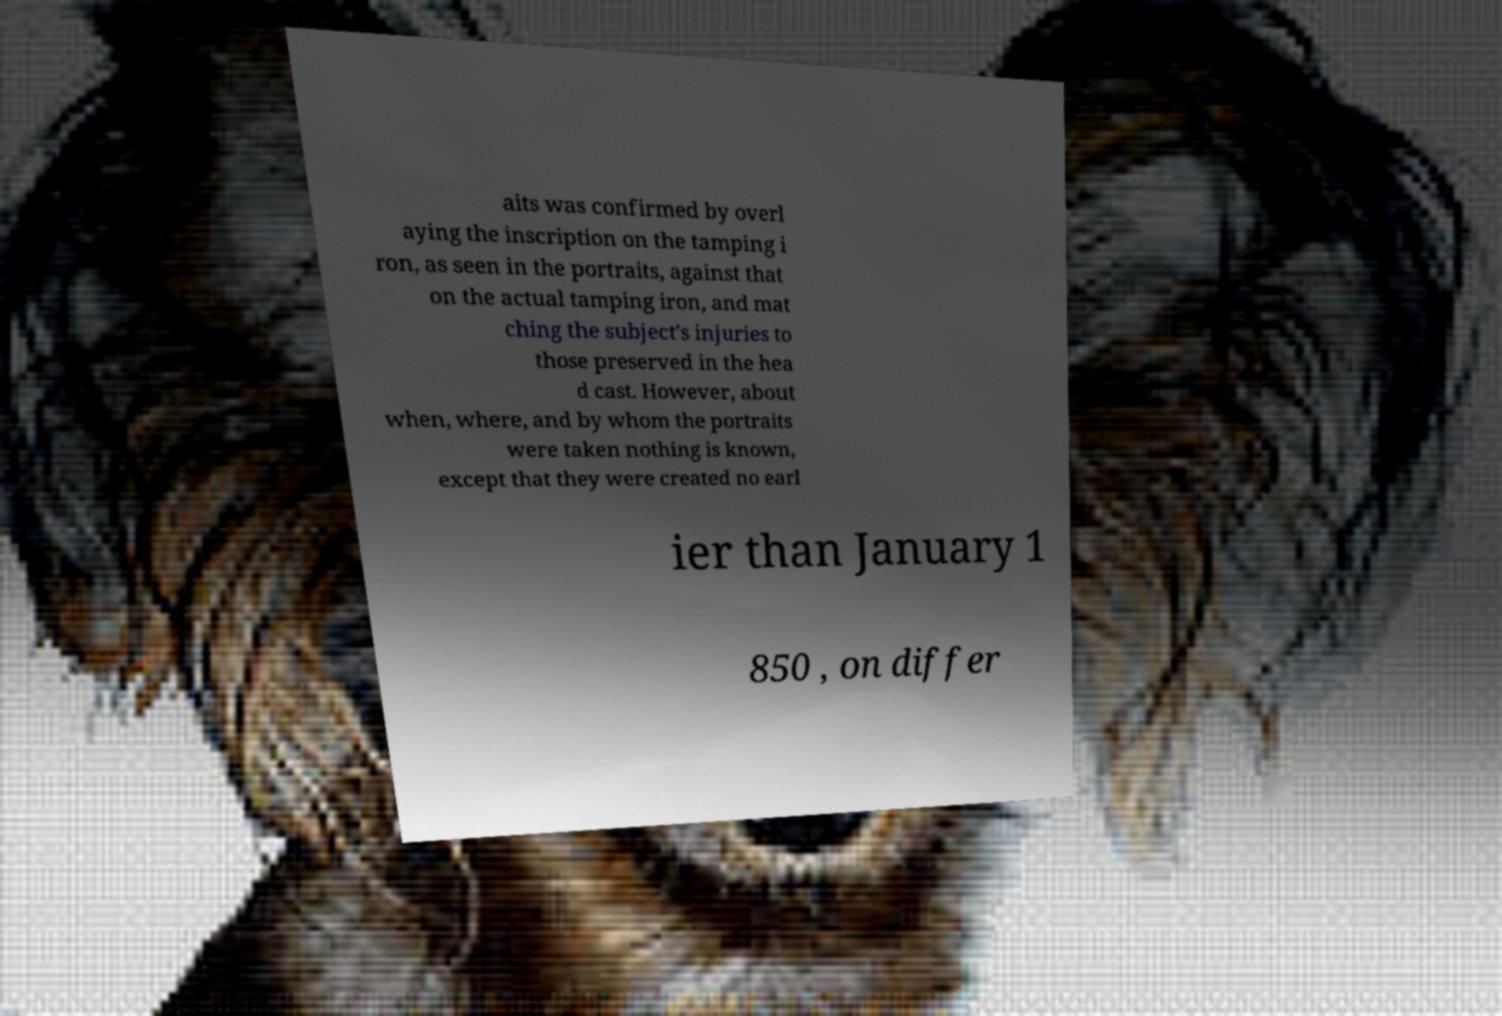Could you assist in decoding the text presented in this image and type it out clearly? aits was confirmed by overl aying the inscription on the tamping i ron, as seen in the portraits, against that on the actual tamping iron, and mat ching the subject's injuries to those preserved in the hea d cast. However, about when, where, and by whom the portraits were taken nothing is known, except that they were created no earl ier than January 1 850 , on differ 